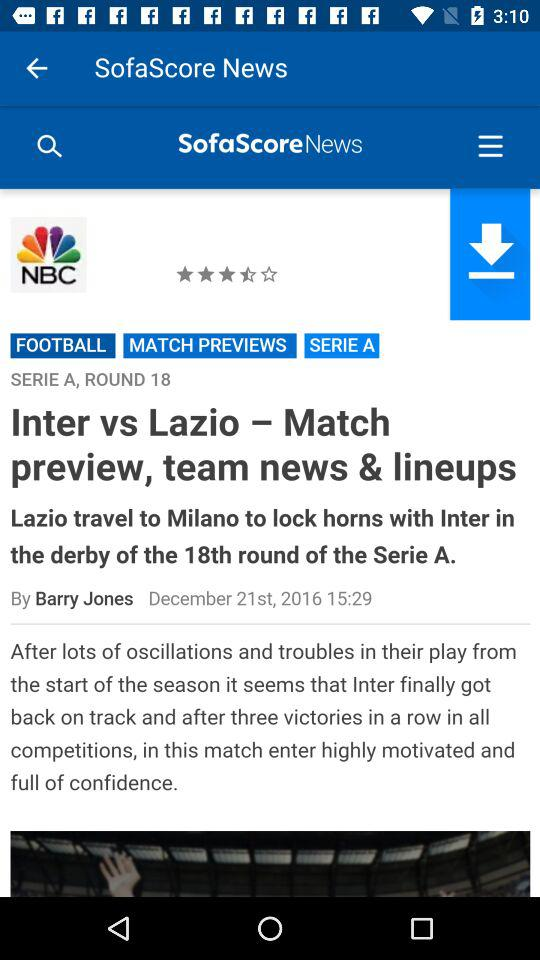What is the round number? The round number is 18. 